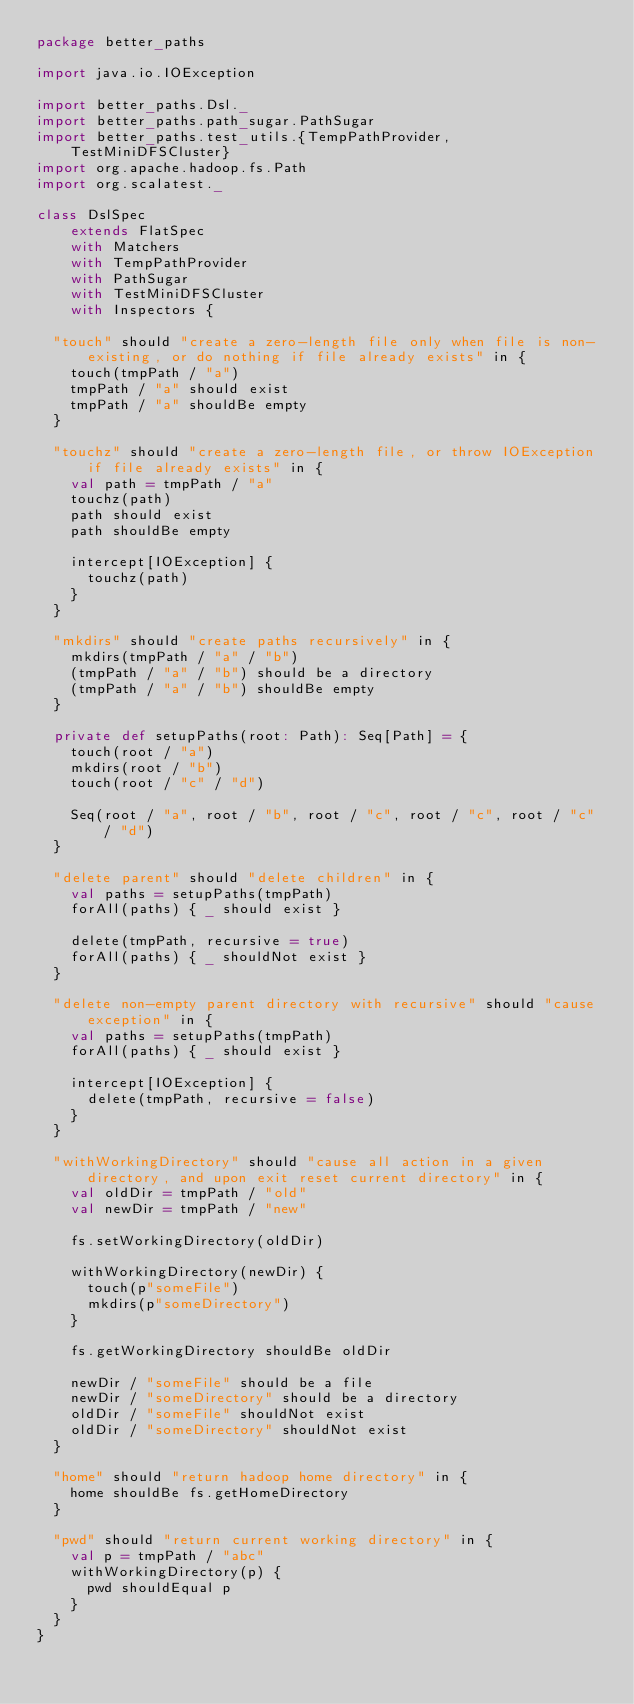Convert code to text. <code><loc_0><loc_0><loc_500><loc_500><_Scala_>package better_paths

import java.io.IOException

import better_paths.Dsl._
import better_paths.path_sugar.PathSugar
import better_paths.test_utils.{TempPathProvider, TestMiniDFSCluster}
import org.apache.hadoop.fs.Path
import org.scalatest._

class DslSpec
    extends FlatSpec
    with Matchers
    with TempPathProvider
    with PathSugar
    with TestMiniDFSCluster
    with Inspectors {

  "touch" should "create a zero-length file only when file is non-existing, or do nothing if file already exists" in {
    touch(tmpPath / "a")
    tmpPath / "a" should exist
    tmpPath / "a" shouldBe empty
  }

  "touchz" should "create a zero-length file, or throw IOException if file already exists" in {
    val path = tmpPath / "a"
    touchz(path)
    path should exist
    path shouldBe empty

    intercept[IOException] {
      touchz(path)
    }
  }

  "mkdirs" should "create paths recursively" in {
    mkdirs(tmpPath / "a" / "b")
    (tmpPath / "a" / "b") should be a directory
    (tmpPath / "a" / "b") shouldBe empty
  }

  private def setupPaths(root: Path): Seq[Path] = {
    touch(root / "a")
    mkdirs(root / "b")
    touch(root / "c" / "d")

    Seq(root / "a", root / "b", root / "c", root / "c", root / "c" / "d")
  }

  "delete parent" should "delete children" in {
    val paths = setupPaths(tmpPath)
    forAll(paths) { _ should exist }

    delete(tmpPath, recursive = true)
    forAll(paths) { _ shouldNot exist }
  }

  "delete non-empty parent directory with recursive" should "cause exception" in {
    val paths = setupPaths(tmpPath)
    forAll(paths) { _ should exist }

    intercept[IOException] {
      delete(tmpPath, recursive = false)
    }
  }

  "withWorkingDirectory" should "cause all action in a given directory, and upon exit reset current directory" in {
    val oldDir = tmpPath / "old"
    val newDir = tmpPath / "new"

    fs.setWorkingDirectory(oldDir)

    withWorkingDirectory(newDir) {
      touch(p"someFile")
      mkdirs(p"someDirectory")
    }

    fs.getWorkingDirectory shouldBe oldDir

    newDir / "someFile" should be a file
    newDir / "someDirectory" should be a directory
    oldDir / "someFile" shouldNot exist
    oldDir / "someDirectory" shouldNot exist
  }

  "home" should "return hadoop home directory" in {
    home shouldBe fs.getHomeDirectory
  }

  "pwd" should "return current working directory" in {
    val p = tmpPath / "abc"
    withWorkingDirectory(p) {
      pwd shouldEqual p
    }
  }
}
</code> 